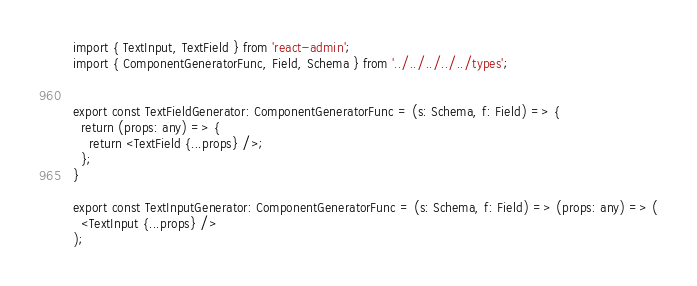<code> <loc_0><loc_0><loc_500><loc_500><_TypeScript_>import { TextInput, TextField } from 'react-admin';
import { ComponentGeneratorFunc, Field, Schema } from '../../../../../types';


export const TextFieldGenerator: ComponentGeneratorFunc = (s: Schema, f: Field) => {
  return (props: any) => {
    return <TextField {...props} />;
  };
}

export const TextInputGenerator: ComponentGeneratorFunc = (s: Schema, f: Field) => (props: any) => (
  <TextInput {...props} />
);
</code> 